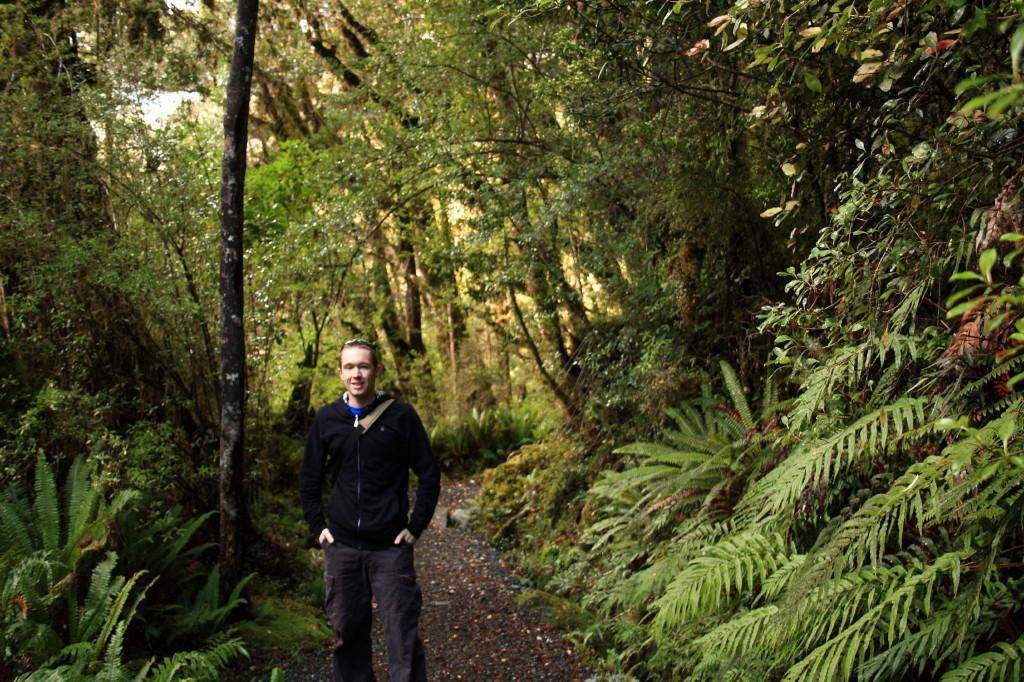Could you give a brief overview of what you see in this image? In this image a person wearing a black jacket is standing on the path. Background there are few plants and trees on the land. 